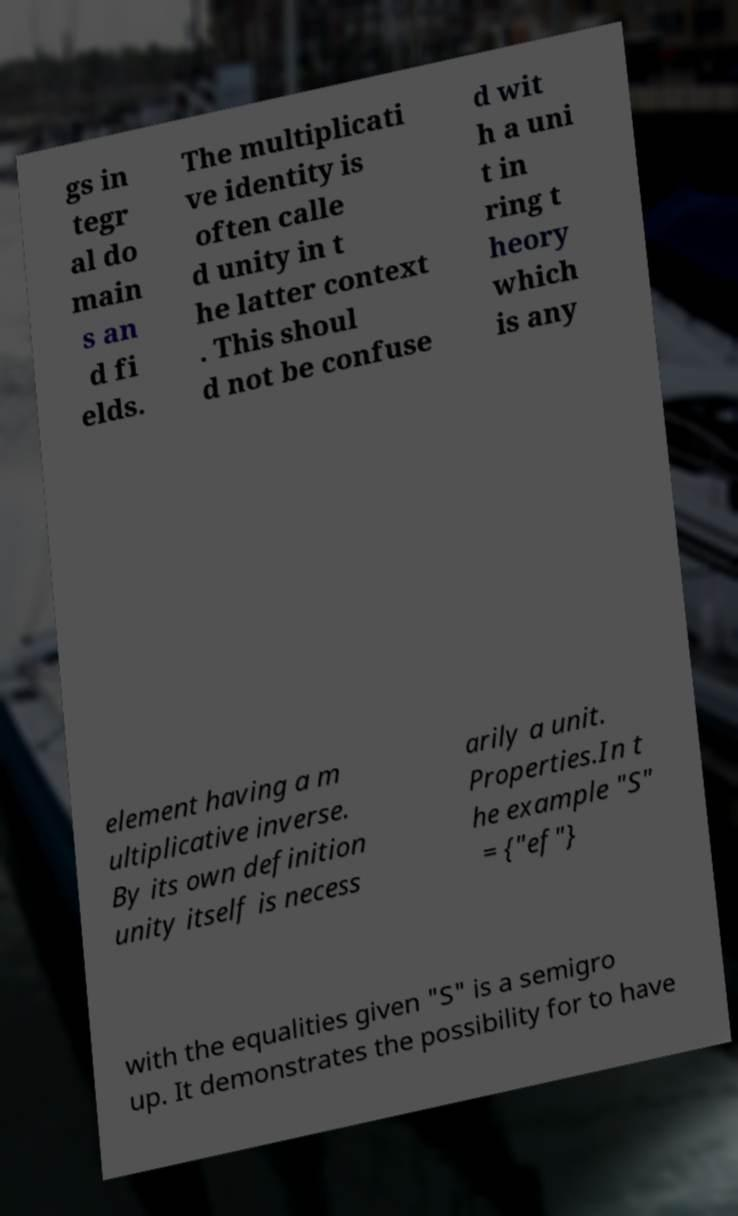For documentation purposes, I need the text within this image transcribed. Could you provide that? gs in tegr al do main s an d fi elds. The multiplicati ve identity is often calle d unity in t he latter context . This shoul d not be confuse d wit h a uni t in ring t heory which is any element having a m ultiplicative inverse. By its own definition unity itself is necess arily a unit. Properties.In t he example "S" = {"ef"} with the equalities given "S" is a semigro up. It demonstrates the possibility for to have 